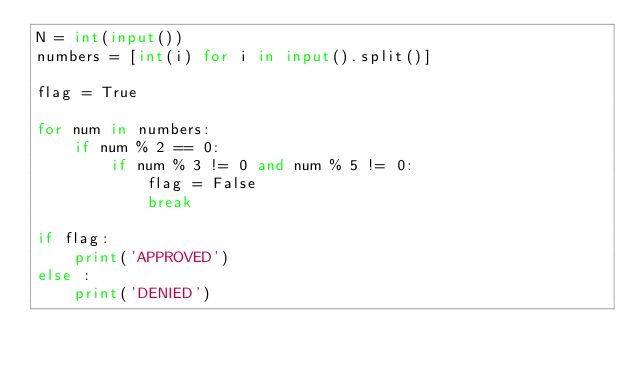Convert code to text. <code><loc_0><loc_0><loc_500><loc_500><_Python_>N = int(input())
numbers = [int(i) for i in input().split()]

flag = True

for num in numbers:
    if num % 2 == 0:
        if num % 3 != 0 and num % 5 != 0:
            flag = False
            break
            
if flag:
    print('APPROVED')
else :
    print('DENIED')</code> 